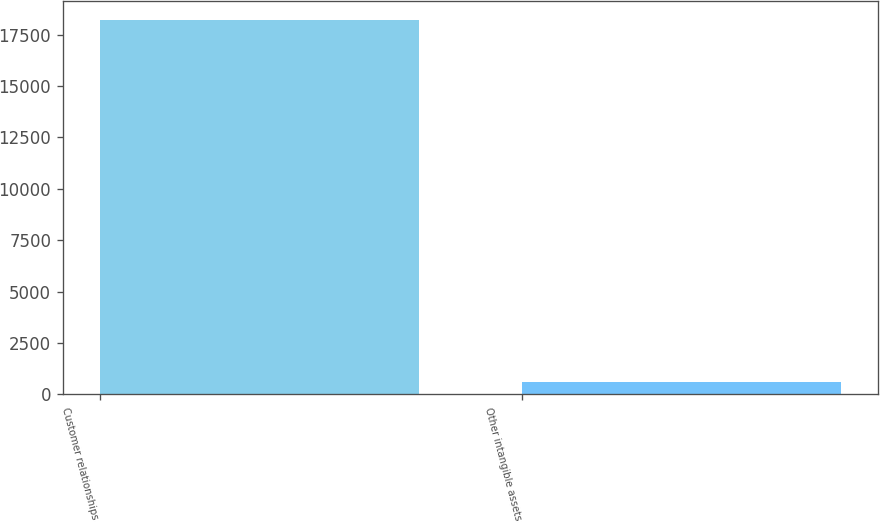<chart> <loc_0><loc_0><loc_500><loc_500><bar_chart><fcel>Customer relationships<fcel>Other intangible assets<nl><fcel>18226<fcel>615<nl></chart> 